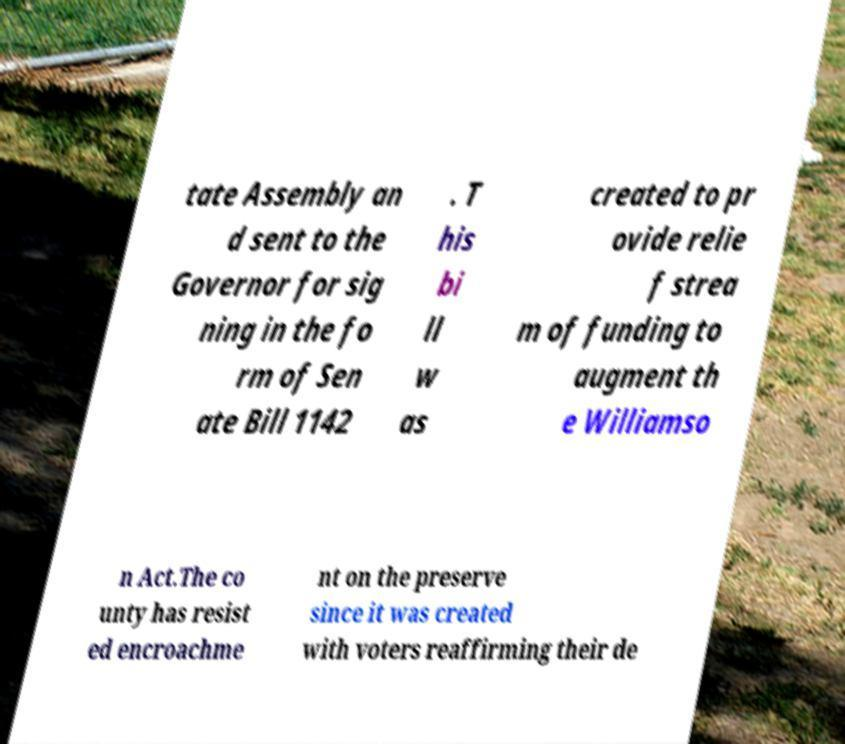Could you extract and type out the text from this image? tate Assembly an d sent to the Governor for sig ning in the fo rm of Sen ate Bill 1142 . T his bi ll w as created to pr ovide relie f strea m of funding to augment th e Williamso n Act.The co unty has resist ed encroachme nt on the preserve since it was created with voters reaffirming their de 